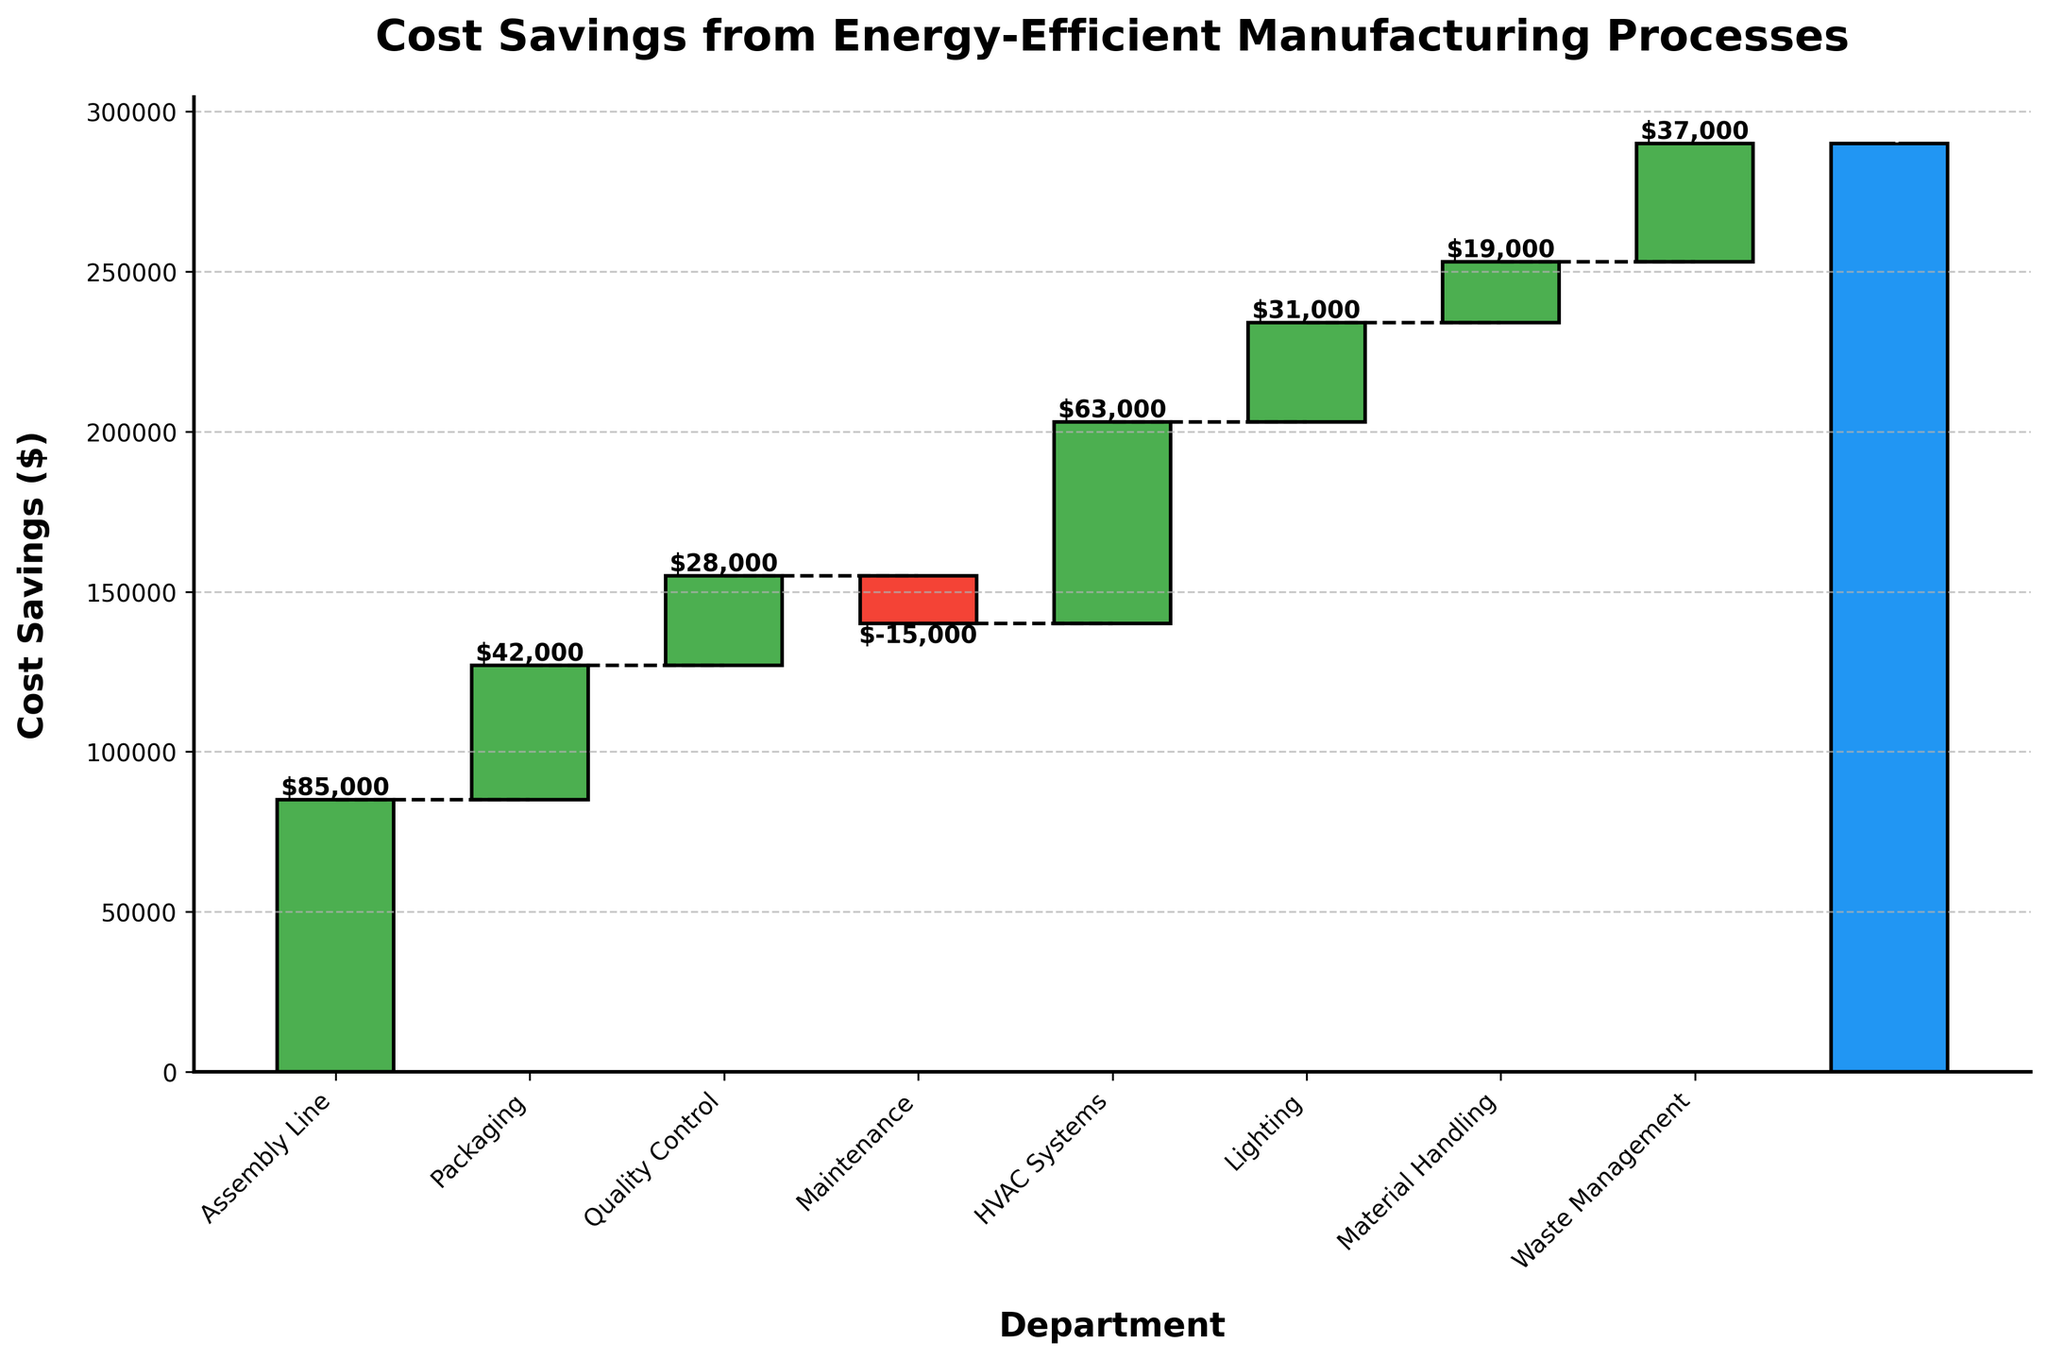what is the title of the chart? The title is located at the top of the chart and provides a summary of what the chart is about.
Answer: Cost Savings from Energy-Efficient Manufacturing Processes Which department had the highest cost savings? Look at the tallest positive bar on the chart.
Answer: Assembly Line What is the total cost savings across all departments? Refer to the total bar at the end of the waterfall chart labeled "Total."
Answer: $290,000 Which department showed a cost increase instead of savings? Identify the bar that extends downward or is colored differently to signify an increase in costs.
Answer: Maintenance What are the cumulative savings from the first three departments (Assembly Line, Packaging, Quality Control)? Sum the individual savings of the first three departments: $85,000 (Assembly Line) + $42,000 (Packaging) + $28,000 (Quality Control). 85000 + 42000 + 28000 = 155000
Answer: $155,000 How does the cost savings from HVAC Systems compare to Waste Management? Look at the heights of the bars for HVAC Systems and Waste Management and compare their values.
Answer: $63,000 vs. $37,000 What is the difference in cost savings between the Packaging department and the Lighting department? Subtract the cost savings of the Lighting department from the Packaging department. 42000 - 31000 = 11000
Answer: $11,000 What are the combined cost savings of Material Handling and Waste Management? Add the cost savings of Material Handling and Waste Management. 19000 + 37000 = 56000
Answer: $56,000 How much does the Maintenance department's cost increase impact the overall total savings? Add the negative value of the Maintenance department's costs to the total without considering Maintenance ($290,000 + $15,000). 290000 + 15000 = 305000
Answer: $15,000 If Maintenance costs were zero, what would the new total cost savings be? Add the current Maintenance cost to the overall total savings: $290,000 + $15,000. 290000 + 15000 = 305000
Answer: $305,000 